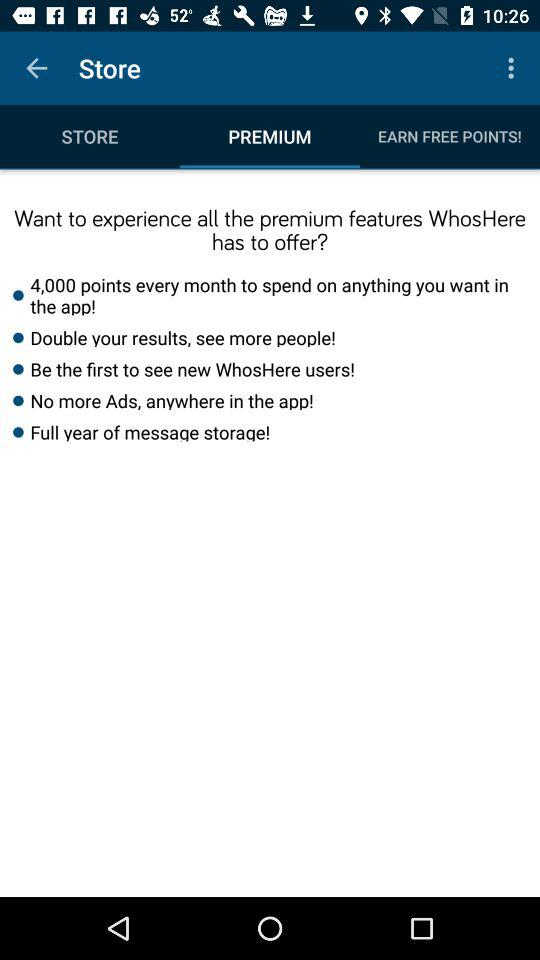How many more premium features does the premium subscription offer than the free subscription?
Answer the question using a single word or phrase. 5 